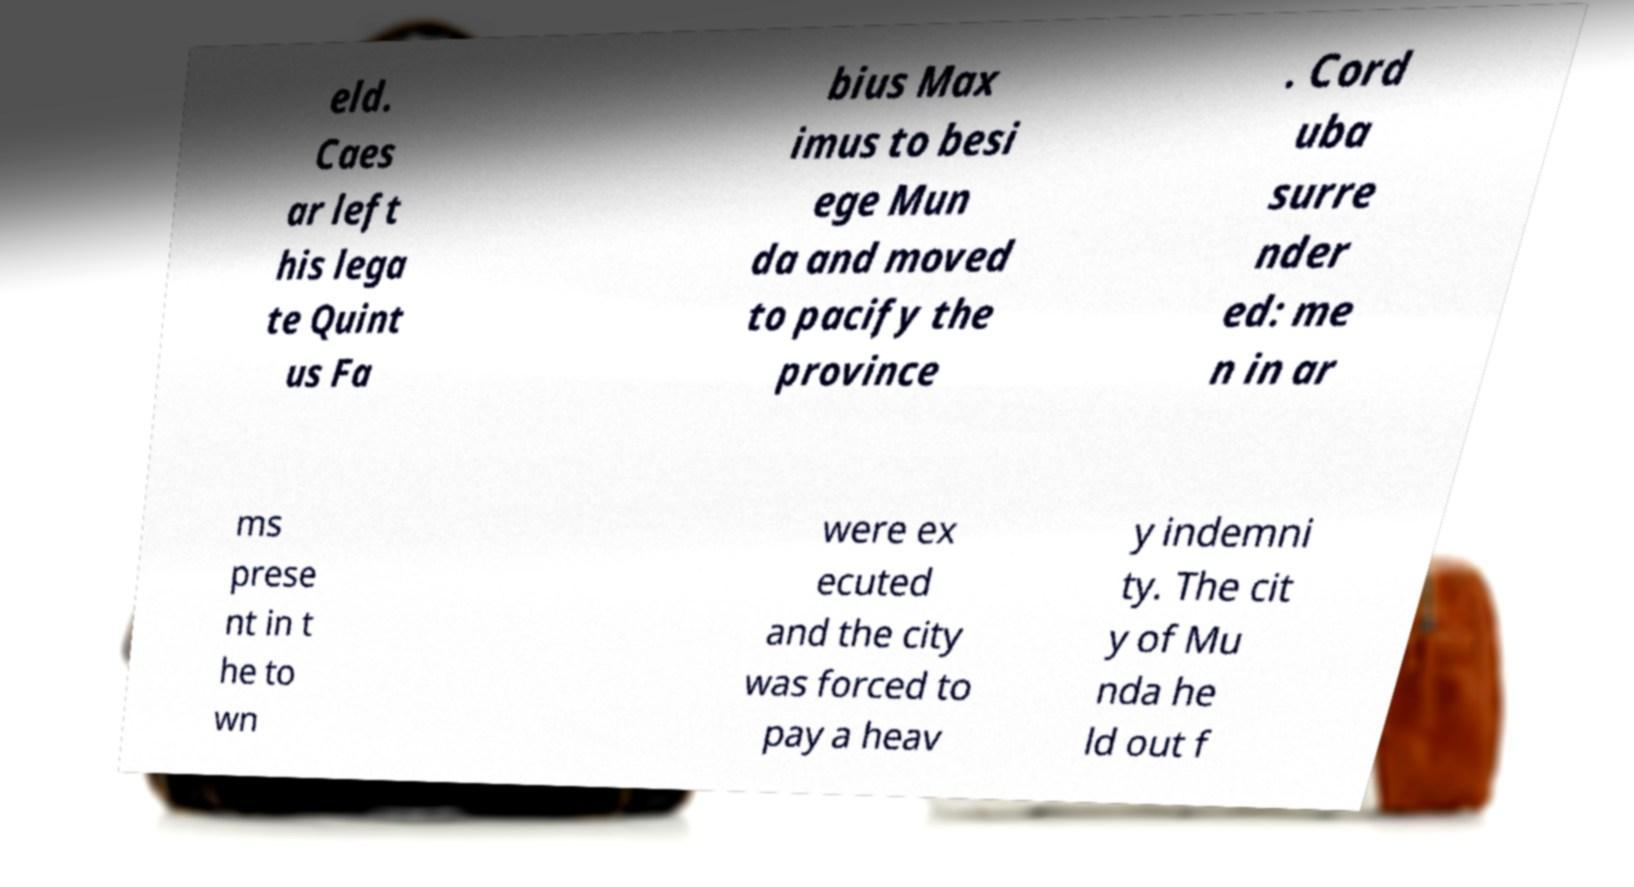Can you read and provide the text displayed in the image?This photo seems to have some interesting text. Can you extract and type it out for me? eld. Caes ar left his lega te Quint us Fa bius Max imus to besi ege Mun da and moved to pacify the province . Cord uba surre nder ed: me n in ar ms prese nt in t he to wn were ex ecuted and the city was forced to pay a heav y indemni ty. The cit y of Mu nda he ld out f 